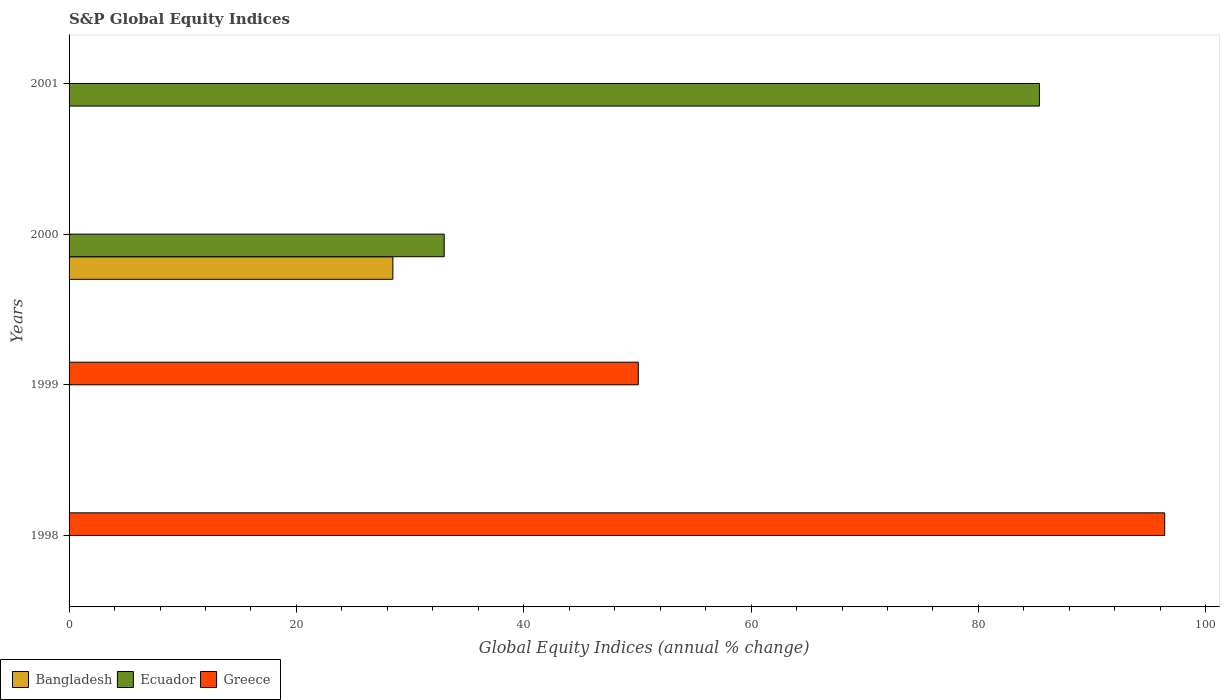How many different coloured bars are there?
Make the answer very short. 3. How many bars are there on the 1st tick from the top?
Ensure brevity in your answer.  1. What is the global equity indices in Greece in 1999?
Provide a short and direct response. 50.08. Across all years, what is the maximum global equity indices in Ecuador?
Make the answer very short. 85.37. Across all years, what is the minimum global equity indices in Ecuador?
Your answer should be very brief. 0. What is the total global equity indices in Bangladesh in the graph?
Provide a short and direct response. 28.49. What is the difference between the global equity indices in Ecuador in 2000 and that in 2001?
Provide a succinct answer. -52.36. What is the average global equity indices in Greece per year?
Your answer should be compact. 36.62. In the year 2000, what is the difference between the global equity indices in Ecuador and global equity indices in Bangladesh?
Your answer should be very brief. 4.52. Is the global equity indices in Ecuador in 2000 less than that in 2001?
Your answer should be compact. Yes. What is the difference between the highest and the lowest global equity indices in Ecuador?
Your response must be concise. 85.37. How many bars are there?
Keep it short and to the point. 5. Are the values on the major ticks of X-axis written in scientific E-notation?
Provide a succinct answer. No. Does the graph contain any zero values?
Make the answer very short. Yes. Where does the legend appear in the graph?
Offer a terse response. Bottom left. How many legend labels are there?
Ensure brevity in your answer.  3. What is the title of the graph?
Provide a succinct answer. S&P Global Equity Indices. What is the label or title of the X-axis?
Provide a short and direct response. Global Equity Indices (annual % change). What is the Global Equity Indices (annual % change) of Ecuador in 1998?
Offer a very short reply. 0. What is the Global Equity Indices (annual % change) in Greece in 1998?
Ensure brevity in your answer.  96.39. What is the Global Equity Indices (annual % change) of Ecuador in 1999?
Offer a very short reply. 0. What is the Global Equity Indices (annual % change) in Greece in 1999?
Make the answer very short. 50.08. What is the Global Equity Indices (annual % change) of Bangladesh in 2000?
Ensure brevity in your answer.  28.49. What is the Global Equity Indices (annual % change) in Ecuador in 2000?
Your answer should be compact. 33. What is the Global Equity Indices (annual % change) of Greece in 2000?
Your answer should be compact. 0. What is the Global Equity Indices (annual % change) in Bangladesh in 2001?
Your answer should be very brief. 0. What is the Global Equity Indices (annual % change) of Ecuador in 2001?
Offer a very short reply. 85.37. What is the Global Equity Indices (annual % change) of Greece in 2001?
Ensure brevity in your answer.  0. Across all years, what is the maximum Global Equity Indices (annual % change) in Bangladesh?
Keep it short and to the point. 28.49. Across all years, what is the maximum Global Equity Indices (annual % change) of Ecuador?
Offer a terse response. 85.37. Across all years, what is the maximum Global Equity Indices (annual % change) in Greece?
Ensure brevity in your answer.  96.39. Across all years, what is the minimum Global Equity Indices (annual % change) of Ecuador?
Offer a terse response. 0. Across all years, what is the minimum Global Equity Indices (annual % change) of Greece?
Your answer should be very brief. 0. What is the total Global Equity Indices (annual % change) in Bangladesh in the graph?
Ensure brevity in your answer.  28.49. What is the total Global Equity Indices (annual % change) in Ecuador in the graph?
Your response must be concise. 118.37. What is the total Global Equity Indices (annual % change) of Greece in the graph?
Offer a terse response. 146.47. What is the difference between the Global Equity Indices (annual % change) of Greece in 1998 and that in 1999?
Offer a terse response. 46.31. What is the difference between the Global Equity Indices (annual % change) of Ecuador in 2000 and that in 2001?
Provide a short and direct response. -52.36. What is the difference between the Global Equity Indices (annual % change) of Bangladesh in 2000 and the Global Equity Indices (annual % change) of Ecuador in 2001?
Make the answer very short. -56.88. What is the average Global Equity Indices (annual % change) of Bangladesh per year?
Keep it short and to the point. 7.12. What is the average Global Equity Indices (annual % change) of Ecuador per year?
Your answer should be compact. 29.59. What is the average Global Equity Indices (annual % change) of Greece per year?
Make the answer very short. 36.62. In the year 2000, what is the difference between the Global Equity Indices (annual % change) of Bangladesh and Global Equity Indices (annual % change) of Ecuador?
Offer a terse response. -4.52. What is the ratio of the Global Equity Indices (annual % change) in Greece in 1998 to that in 1999?
Make the answer very short. 1.92. What is the ratio of the Global Equity Indices (annual % change) of Ecuador in 2000 to that in 2001?
Provide a short and direct response. 0.39. What is the difference between the highest and the lowest Global Equity Indices (annual % change) of Bangladesh?
Offer a terse response. 28.49. What is the difference between the highest and the lowest Global Equity Indices (annual % change) of Ecuador?
Offer a terse response. 85.37. What is the difference between the highest and the lowest Global Equity Indices (annual % change) of Greece?
Offer a terse response. 96.39. 